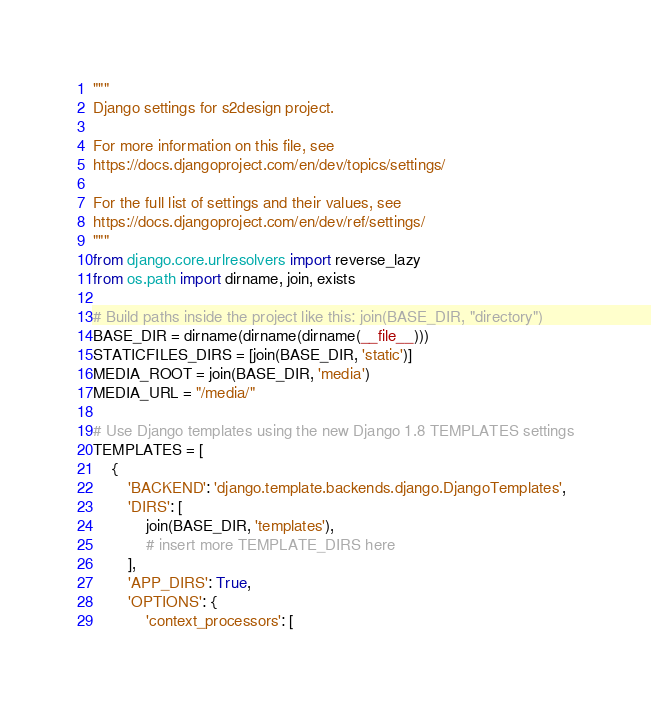<code> <loc_0><loc_0><loc_500><loc_500><_Python_>"""
Django settings for s2design project.

For more information on this file, see
https://docs.djangoproject.com/en/dev/topics/settings/

For the full list of settings and their values, see
https://docs.djangoproject.com/en/dev/ref/settings/
"""
from django.core.urlresolvers import reverse_lazy
from os.path import dirname, join, exists

# Build paths inside the project like this: join(BASE_DIR, "directory")
BASE_DIR = dirname(dirname(dirname(__file__)))
STATICFILES_DIRS = [join(BASE_DIR, 'static')]
MEDIA_ROOT = join(BASE_DIR, 'media')
MEDIA_URL = "/media/"

# Use Django templates using the new Django 1.8 TEMPLATES settings
TEMPLATES = [
    {
        'BACKEND': 'django.template.backends.django.DjangoTemplates',
        'DIRS': [
            join(BASE_DIR, 'templates'),
            # insert more TEMPLATE_DIRS here
        ],
        'APP_DIRS': True,
        'OPTIONS': {
            'context_processors': [</code> 